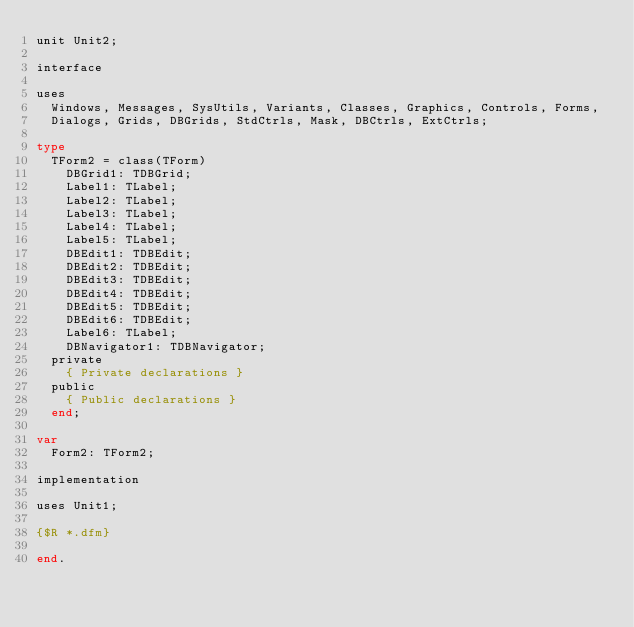<code> <loc_0><loc_0><loc_500><loc_500><_Pascal_>unit Unit2;

interface

uses
  Windows, Messages, SysUtils, Variants, Classes, Graphics, Controls, Forms,
  Dialogs, Grids, DBGrids, StdCtrls, Mask, DBCtrls, ExtCtrls;

type
  TForm2 = class(TForm)
    DBGrid1: TDBGrid;
    Label1: TLabel;
    Label2: TLabel;
    Label3: TLabel;
    Label4: TLabel;
    Label5: TLabel;
    DBEdit1: TDBEdit;
    DBEdit2: TDBEdit;
    DBEdit3: TDBEdit;
    DBEdit4: TDBEdit;
    DBEdit5: TDBEdit;
    DBEdit6: TDBEdit;
    Label6: TLabel;
    DBNavigator1: TDBNavigator;
  private
    { Private declarations }
  public
    { Public declarations }
  end;

var
  Form2: TForm2;

implementation

uses Unit1;

{$R *.dfm}

end.
</code> 